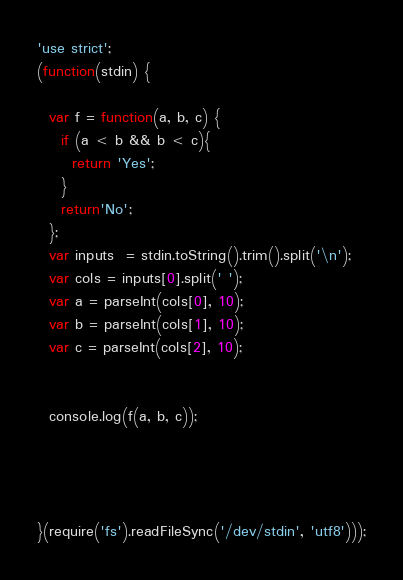<code> <loc_0><loc_0><loc_500><loc_500><_JavaScript_>'use strict';
(function(stdin) {

  var f = function(a, b, c) {
    if (a < b && b < c){
      return 'Yes';
    }
    return'No';
  };
  var inputs  = stdin.toString().trim().split('\n');
  var cols = inputs[0].split(' ');
  var a = parseInt(cols[0], 10);
  var b = parseInt(cols[1], 10);
  var c = parseInt(cols[2], 10);

  
  console.log(f(a, b, c));




}(require('fs').readFileSync('/dev/stdin', 'utf8')));</code> 